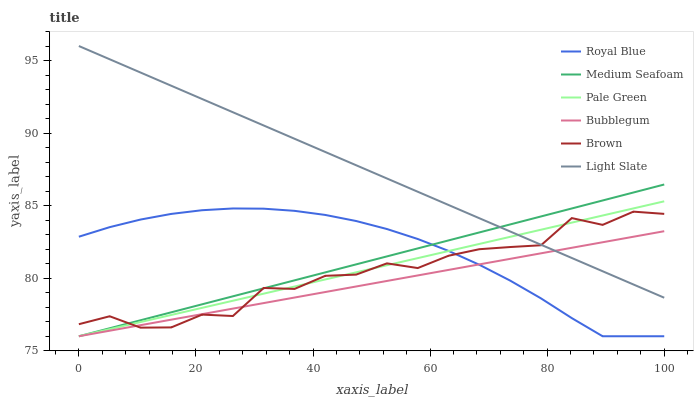Does Bubblegum have the minimum area under the curve?
Answer yes or no. Yes. Does Light Slate have the maximum area under the curve?
Answer yes or no. Yes. Does Light Slate have the minimum area under the curve?
Answer yes or no. No. Does Bubblegum have the maximum area under the curve?
Answer yes or no. No. Is Bubblegum the smoothest?
Answer yes or no. Yes. Is Brown the roughest?
Answer yes or no. Yes. Is Light Slate the smoothest?
Answer yes or no. No. Is Light Slate the roughest?
Answer yes or no. No. Does Bubblegum have the lowest value?
Answer yes or no. Yes. Does Light Slate have the lowest value?
Answer yes or no. No. Does Light Slate have the highest value?
Answer yes or no. Yes. Does Bubblegum have the highest value?
Answer yes or no. No. Is Royal Blue less than Light Slate?
Answer yes or no. Yes. Is Light Slate greater than Royal Blue?
Answer yes or no. Yes. Does Brown intersect Medium Seafoam?
Answer yes or no. Yes. Is Brown less than Medium Seafoam?
Answer yes or no. No. Is Brown greater than Medium Seafoam?
Answer yes or no. No. Does Royal Blue intersect Light Slate?
Answer yes or no. No. 